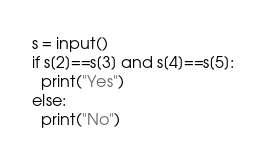Convert code to text. <code><loc_0><loc_0><loc_500><loc_500><_Python_>s = input()
if s[2]==s[3] and s[4]==s[5]:
  print("Yes")
else:
  print("No")</code> 